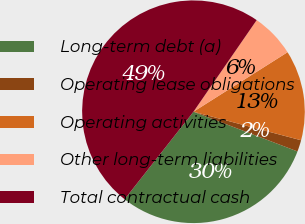Convert chart to OTSL. <chart><loc_0><loc_0><loc_500><loc_500><pie_chart><fcel>Long-term debt (a)<fcel>Operating lease obligations<fcel>Operating activities<fcel>Other long-term liabilities<fcel>Total contractual cash<nl><fcel>29.81%<fcel>1.68%<fcel>13.1%<fcel>6.41%<fcel>49.0%<nl></chart> 